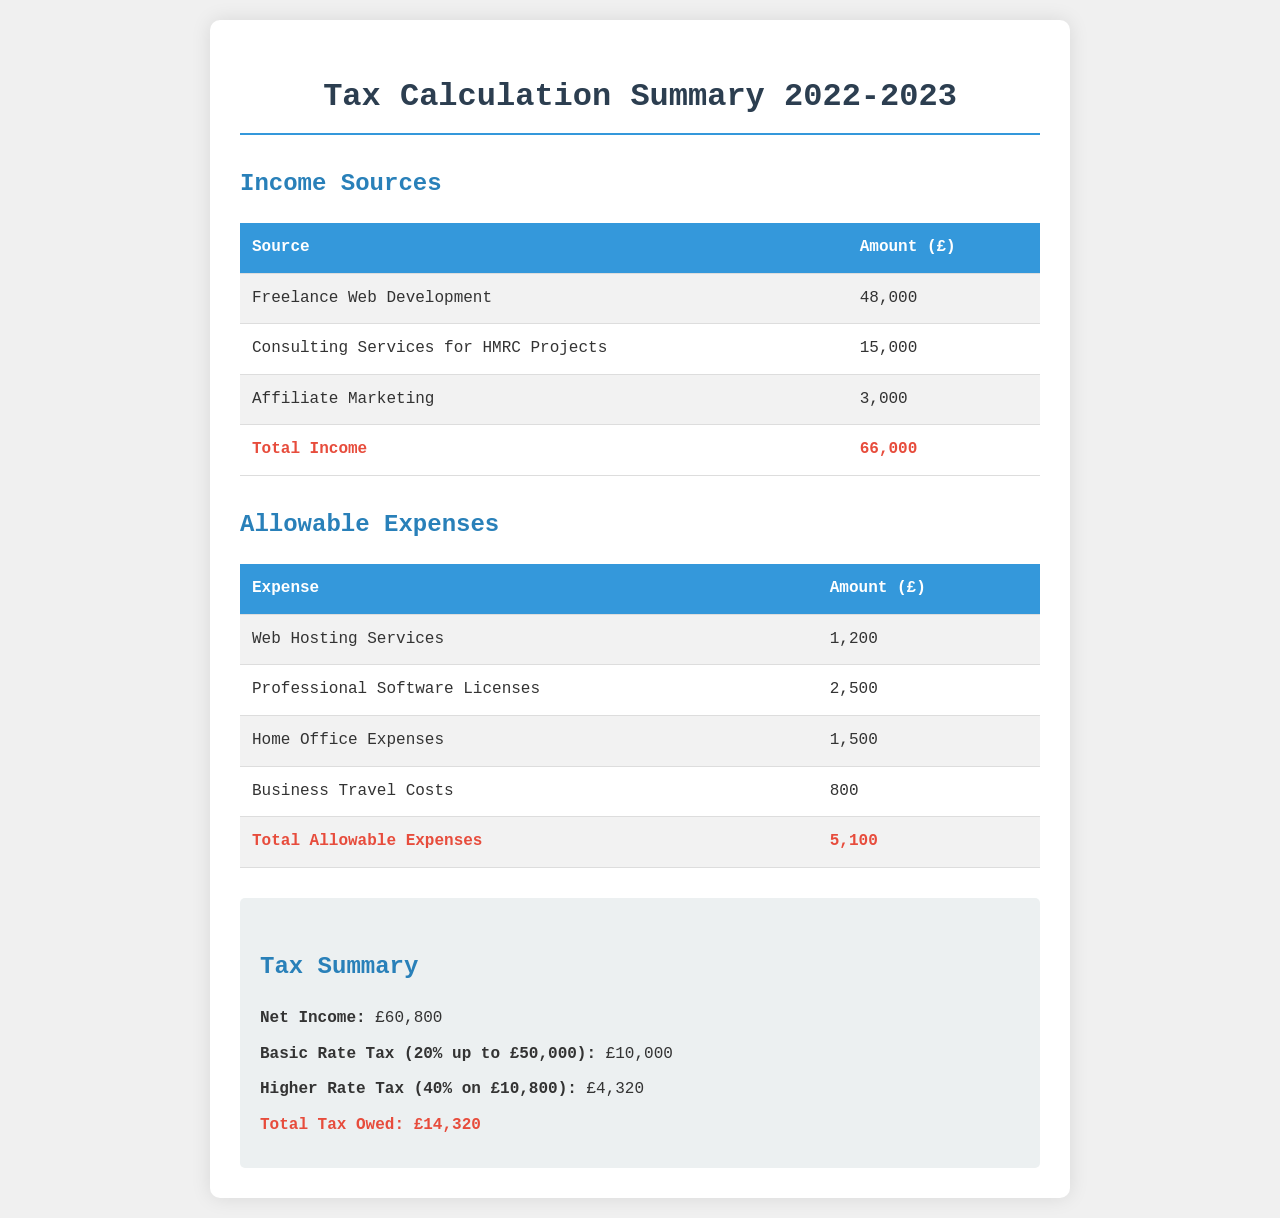What is the total income? The total income is calculated from all the sources of income listed in the document, which are £48,000, £15,000, and £3,000.
Answer: £66,000 What is the amount for business travel costs? The business travel costs are part of the allowable expenses listed and amount to £800.
Answer: £800 What is the total allowable expenses? The total allowable expenses are the sum of all expenses listed in the document: £1,200, £2,500, £1,500, and £800, which equals £5,100.
Answer: £5,100 What is the net income? The net income is calculated by subtracting the total allowable expenses (£5,100) from the total income (£66,000).
Answer: £60,800 What percentage is the basic rate tax? The basic rate tax is specified as 20% on income up to £50,000 in the tax summary section.
Answer: 20% What is the total tax owed? The total tax owed is mentioned in the tax summary, which combines both the basic and higher rate taxes, totaling £14,320.
Answer: £14,320 What are the professional software licenses amount? The professional software licenses are listed in the allowable expenses section, which comes to £2,500.
Answer: £2,500 What is the amount of higher rate tax? The higher rate tax is specified in the summary as £4,320, calculated from income over the basic rate threshold.
Answer: £4,320 What is the source with the highest income? The highest income source listed is freelance web development, which amounts to £48,000.
Answer: Freelance Web Development 